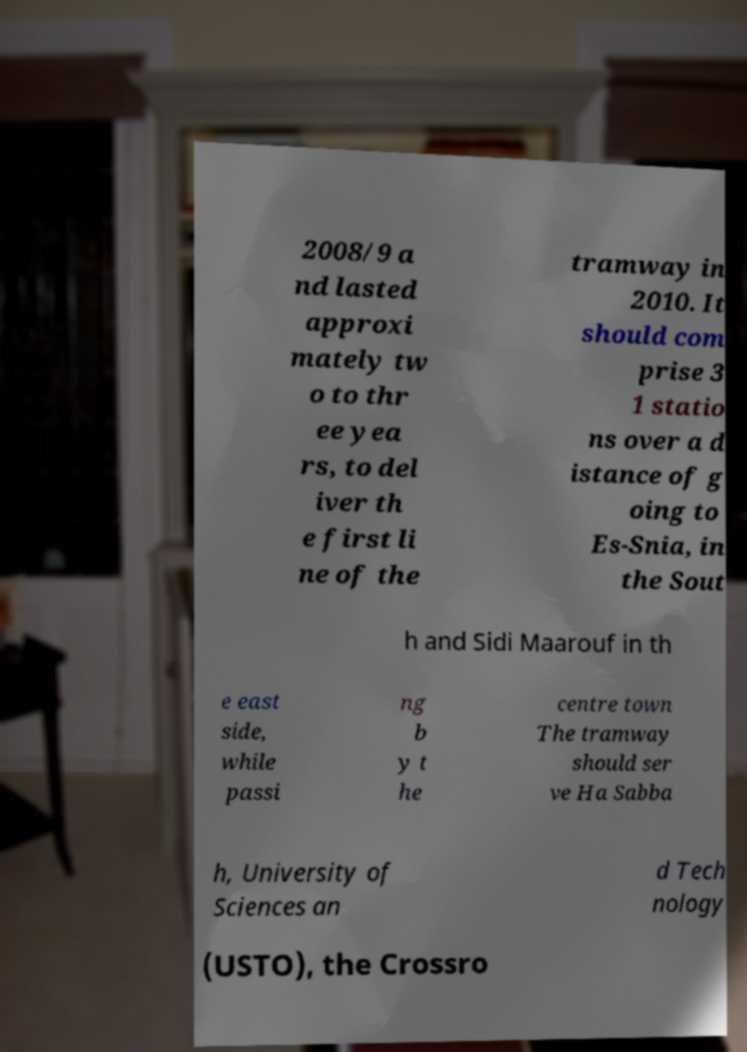Could you extract and type out the text from this image? 2008/9 a nd lasted approxi mately tw o to thr ee yea rs, to del iver th e first li ne of the tramway in 2010. It should com prise 3 1 statio ns over a d istance of g oing to Es-Snia, in the Sout h and Sidi Maarouf in th e east side, while passi ng b y t he centre town The tramway should ser ve Ha Sabba h, University of Sciences an d Tech nology (USTO), the Crossro 